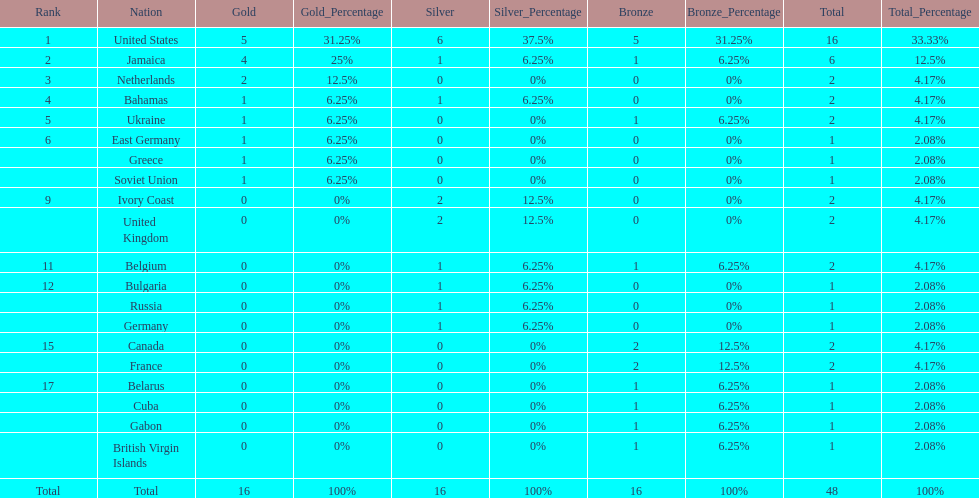What country won more gold medals than any other? United States. 